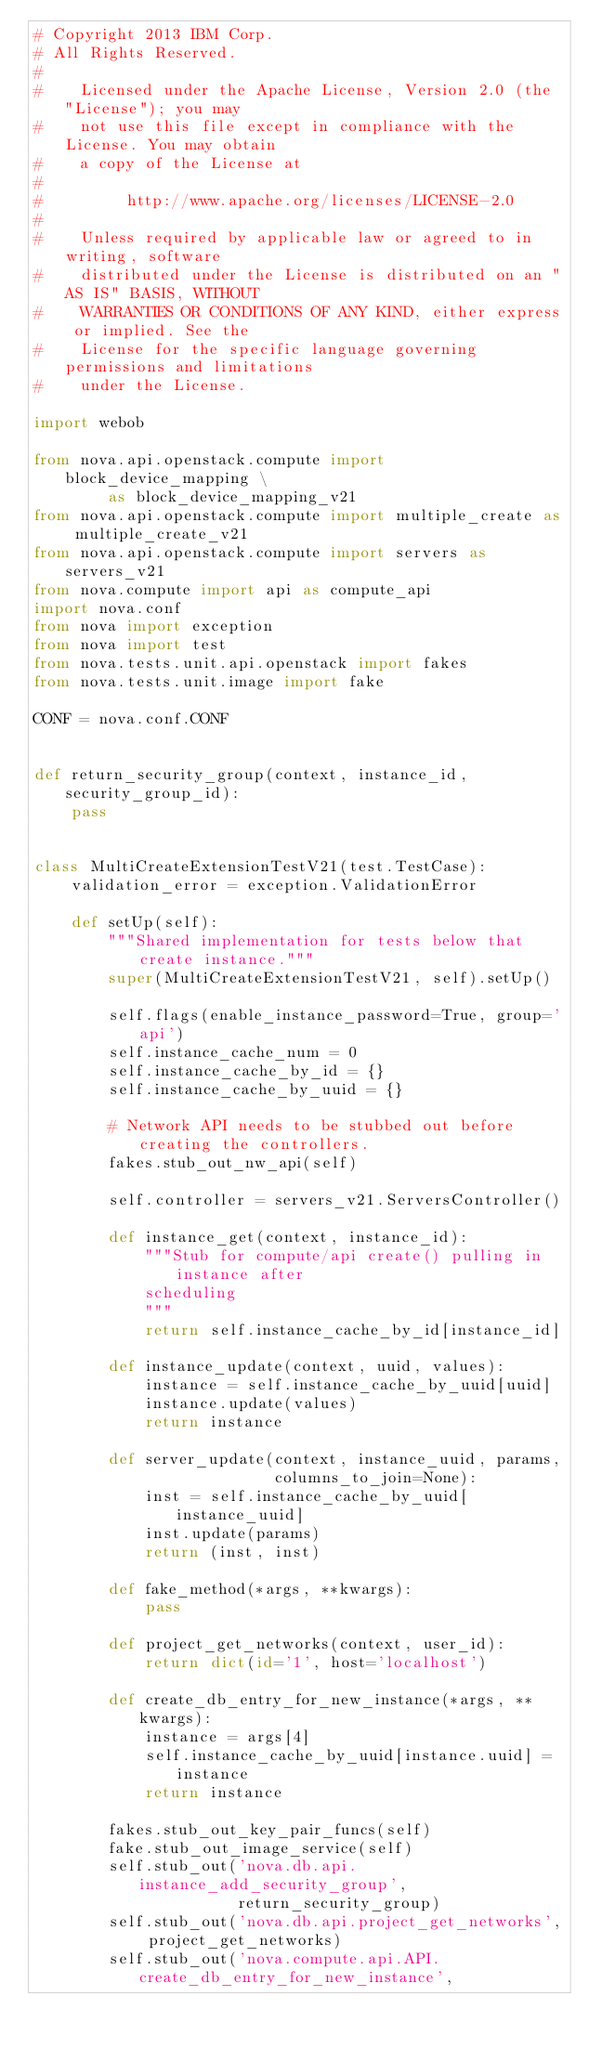<code> <loc_0><loc_0><loc_500><loc_500><_Python_># Copyright 2013 IBM Corp.
# All Rights Reserved.
#
#    Licensed under the Apache License, Version 2.0 (the "License"); you may
#    not use this file except in compliance with the License. You may obtain
#    a copy of the License at
#
#         http://www.apache.org/licenses/LICENSE-2.0
#
#    Unless required by applicable law or agreed to in writing, software
#    distributed under the License is distributed on an "AS IS" BASIS, WITHOUT
#    WARRANTIES OR CONDITIONS OF ANY KIND, either express or implied. See the
#    License for the specific language governing permissions and limitations
#    under the License.

import webob

from nova.api.openstack.compute import block_device_mapping \
        as block_device_mapping_v21
from nova.api.openstack.compute import multiple_create as multiple_create_v21
from nova.api.openstack.compute import servers as servers_v21
from nova.compute import api as compute_api
import nova.conf
from nova import exception
from nova import test
from nova.tests.unit.api.openstack import fakes
from nova.tests.unit.image import fake

CONF = nova.conf.CONF


def return_security_group(context, instance_id, security_group_id):
    pass


class MultiCreateExtensionTestV21(test.TestCase):
    validation_error = exception.ValidationError

    def setUp(self):
        """Shared implementation for tests below that create instance."""
        super(MultiCreateExtensionTestV21, self).setUp()

        self.flags(enable_instance_password=True, group='api')
        self.instance_cache_num = 0
        self.instance_cache_by_id = {}
        self.instance_cache_by_uuid = {}

        # Network API needs to be stubbed out before creating the controllers.
        fakes.stub_out_nw_api(self)

        self.controller = servers_v21.ServersController()

        def instance_get(context, instance_id):
            """Stub for compute/api create() pulling in instance after
            scheduling
            """
            return self.instance_cache_by_id[instance_id]

        def instance_update(context, uuid, values):
            instance = self.instance_cache_by_uuid[uuid]
            instance.update(values)
            return instance

        def server_update(context, instance_uuid, params,
                          columns_to_join=None):
            inst = self.instance_cache_by_uuid[instance_uuid]
            inst.update(params)
            return (inst, inst)

        def fake_method(*args, **kwargs):
            pass

        def project_get_networks(context, user_id):
            return dict(id='1', host='localhost')

        def create_db_entry_for_new_instance(*args, **kwargs):
            instance = args[4]
            self.instance_cache_by_uuid[instance.uuid] = instance
            return instance

        fakes.stub_out_key_pair_funcs(self)
        fake.stub_out_image_service(self)
        self.stub_out('nova.db.api.instance_add_security_group',
                      return_security_group)
        self.stub_out('nova.db.api.project_get_networks', project_get_networks)
        self.stub_out('nova.compute.api.API.create_db_entry_for_new_instance',</code> 